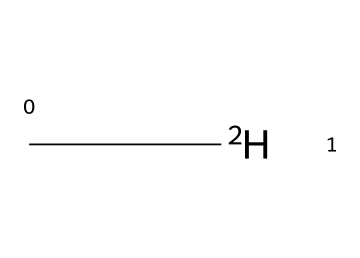What is the atomic symbol for the element in this structure? The chemical structure contains one carbon atom, which is represented by the symbol 'C'. Therefore, the atomic symbol is identified directly from the structure.
Answer: C How many hydrogen atoms are in this compound? Looking at the structure, we see that 'C[2H]' indicates one carbon atom is bonded to two hydrogen atoms. Thus, there are two hydrogen atoms present.
Answer: 2 What type of isotope is represented in this structure? The notation '[2H]' signifies that this is a deuterium isotope, which is a heavier variant of hydrogen due to having one neutron. Therefore, the type of isotope can be determined from this notation.
Answer: deuterium What is the total number of atoms in this molecule? The structure contains one carbon atom and two hydrogen atoms, so we perform the addition: 1 (C) + 2 (H) = 3. Therefore, the total number of atoms in the molecule is obtained by totaling the individual atoms present.
Answer: 3 How does the molecular composition of this compound relate to its application in tracking drug effectiveness? The presence of deuterium (a stable isotope of hydrogen) allows for tracing within metabolic pathways in drug studies, enhancing sensitivity and accuracy in tracking drug distribution and effectiveness. Thus, its composition directly supports its application in healthcare research.
Answer: tracing What functional group can be inferred from this chemical structure? This structure cannot depict specific functional groups like alcohol or ketone due to its simplicity as a labeled isotope. It mainly consists of a combination of carbon and hydrogen with deuterium, indicating it does not exhibit a complex functional group.
Answer: none 